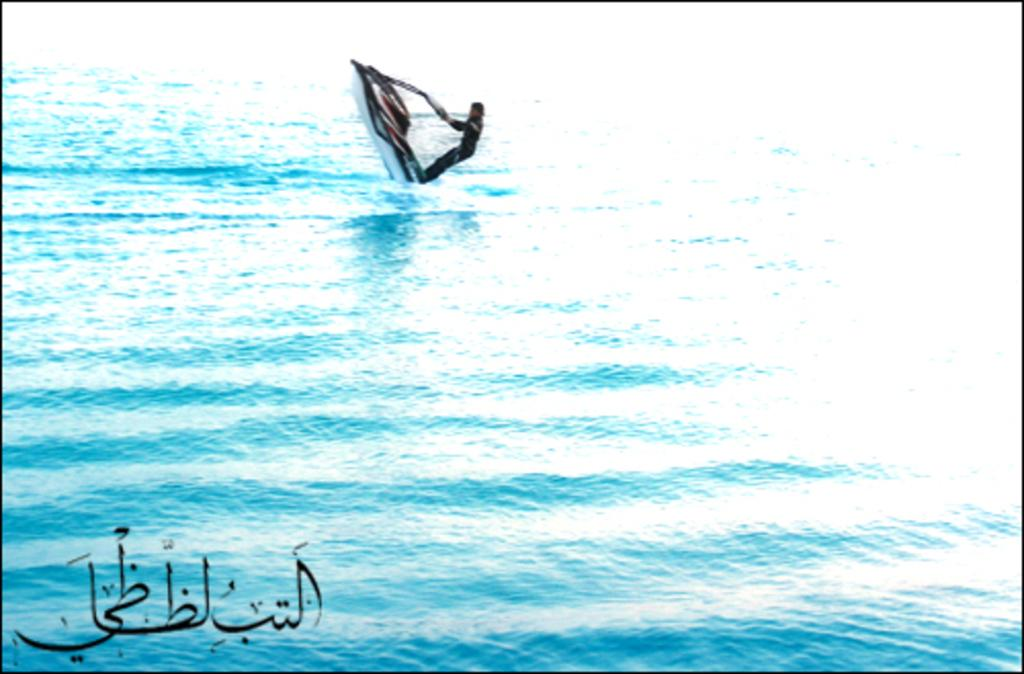What is the main subject of the image? The main subject of the image is a jet boat on the water. Who or what is on the jet boat? There is a person on the jet boat. What is the setting of the image? The setting of the image is on water. What can be found in the left bottom corner of the image? There is text or an image in the left bottom corner of the image. How many ladybugs are crawling on the chin of the person on the jet boat? There are no ladybugs present in the image, and the person's chin is not visible. 